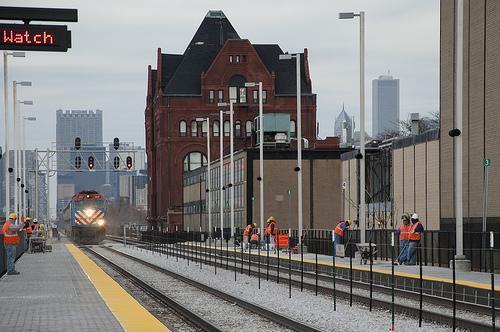How many trains are in the picture?
Give a very brief answer. 1. How many light poles are there in the picture?
Give a very brief answer. 11. How many sets of train tracks are in the picture?
Give a very brief answer. 2. 